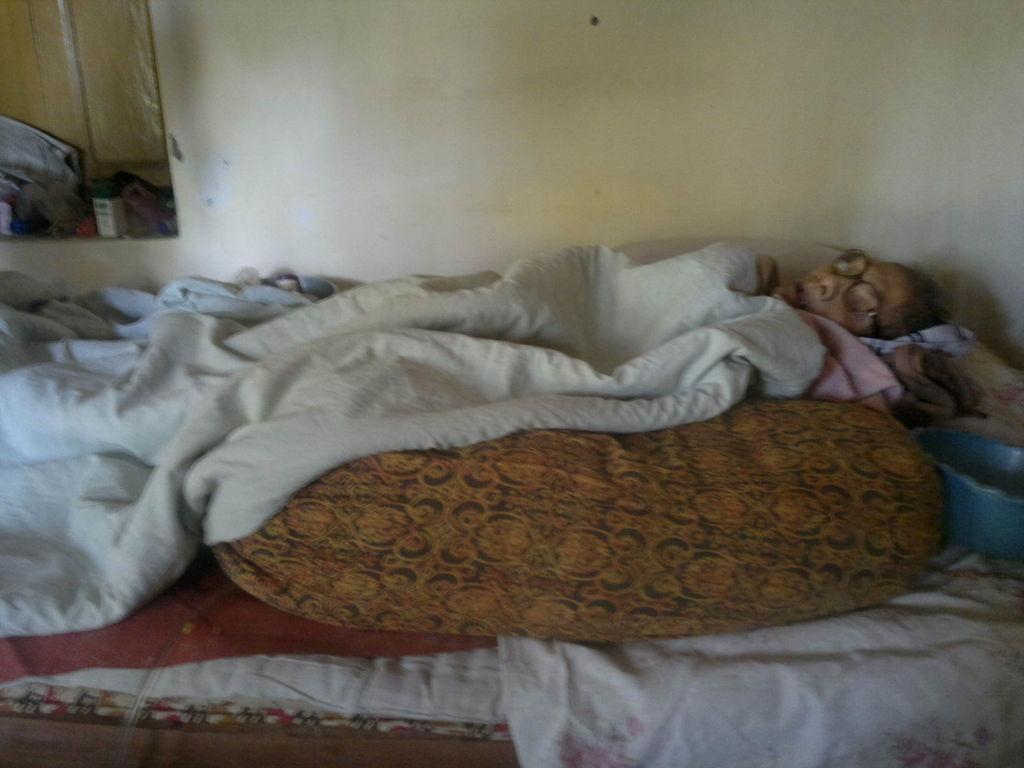Please provide a concise description of this image. In this image there is a person sleeping on the bed, there are blankets, there is an object truncated towards the right of the image, there is the wall truncated towards the top of the image, there are objects truncated towards the left of the image. 